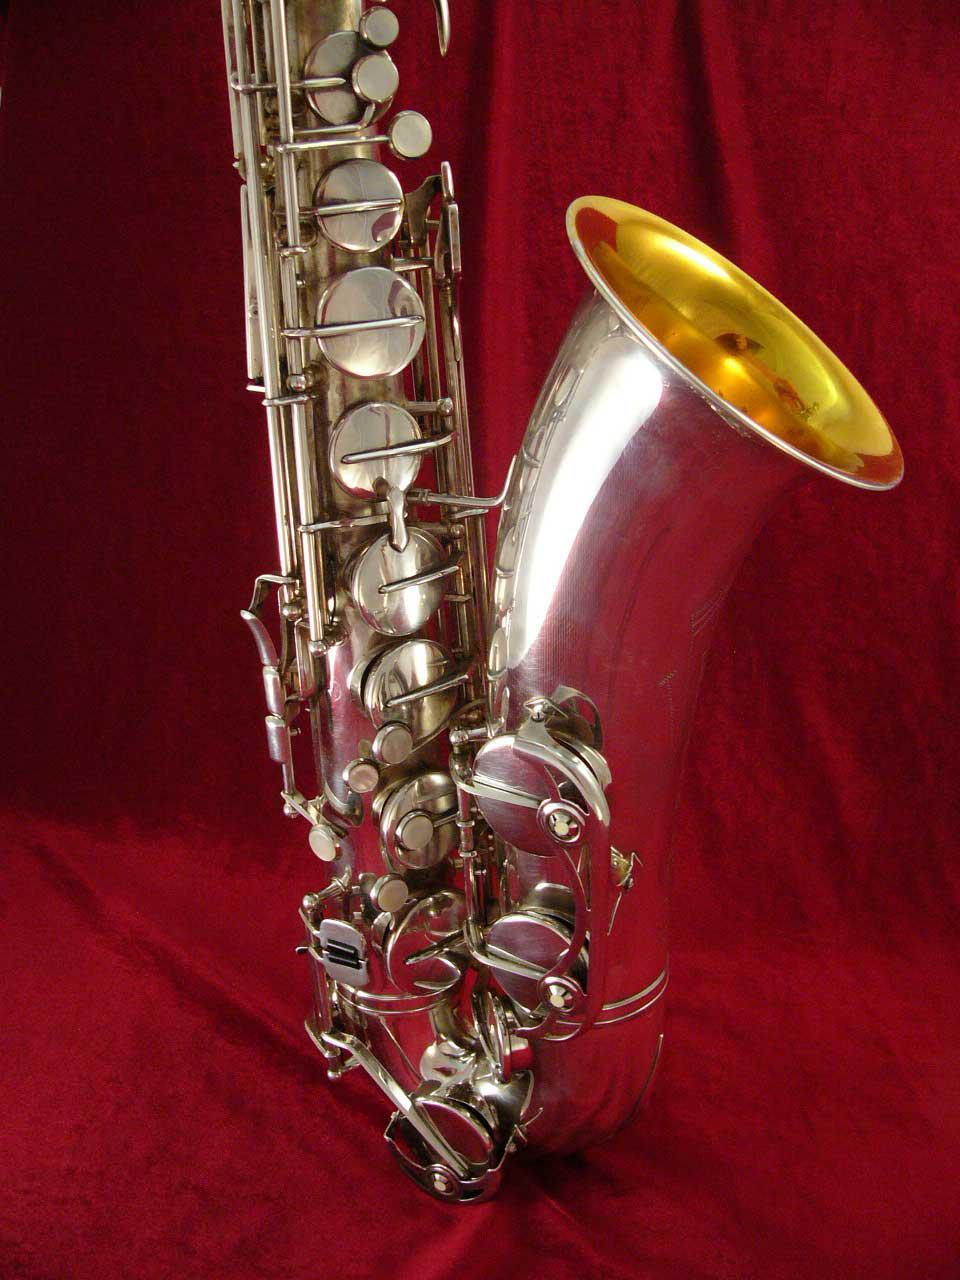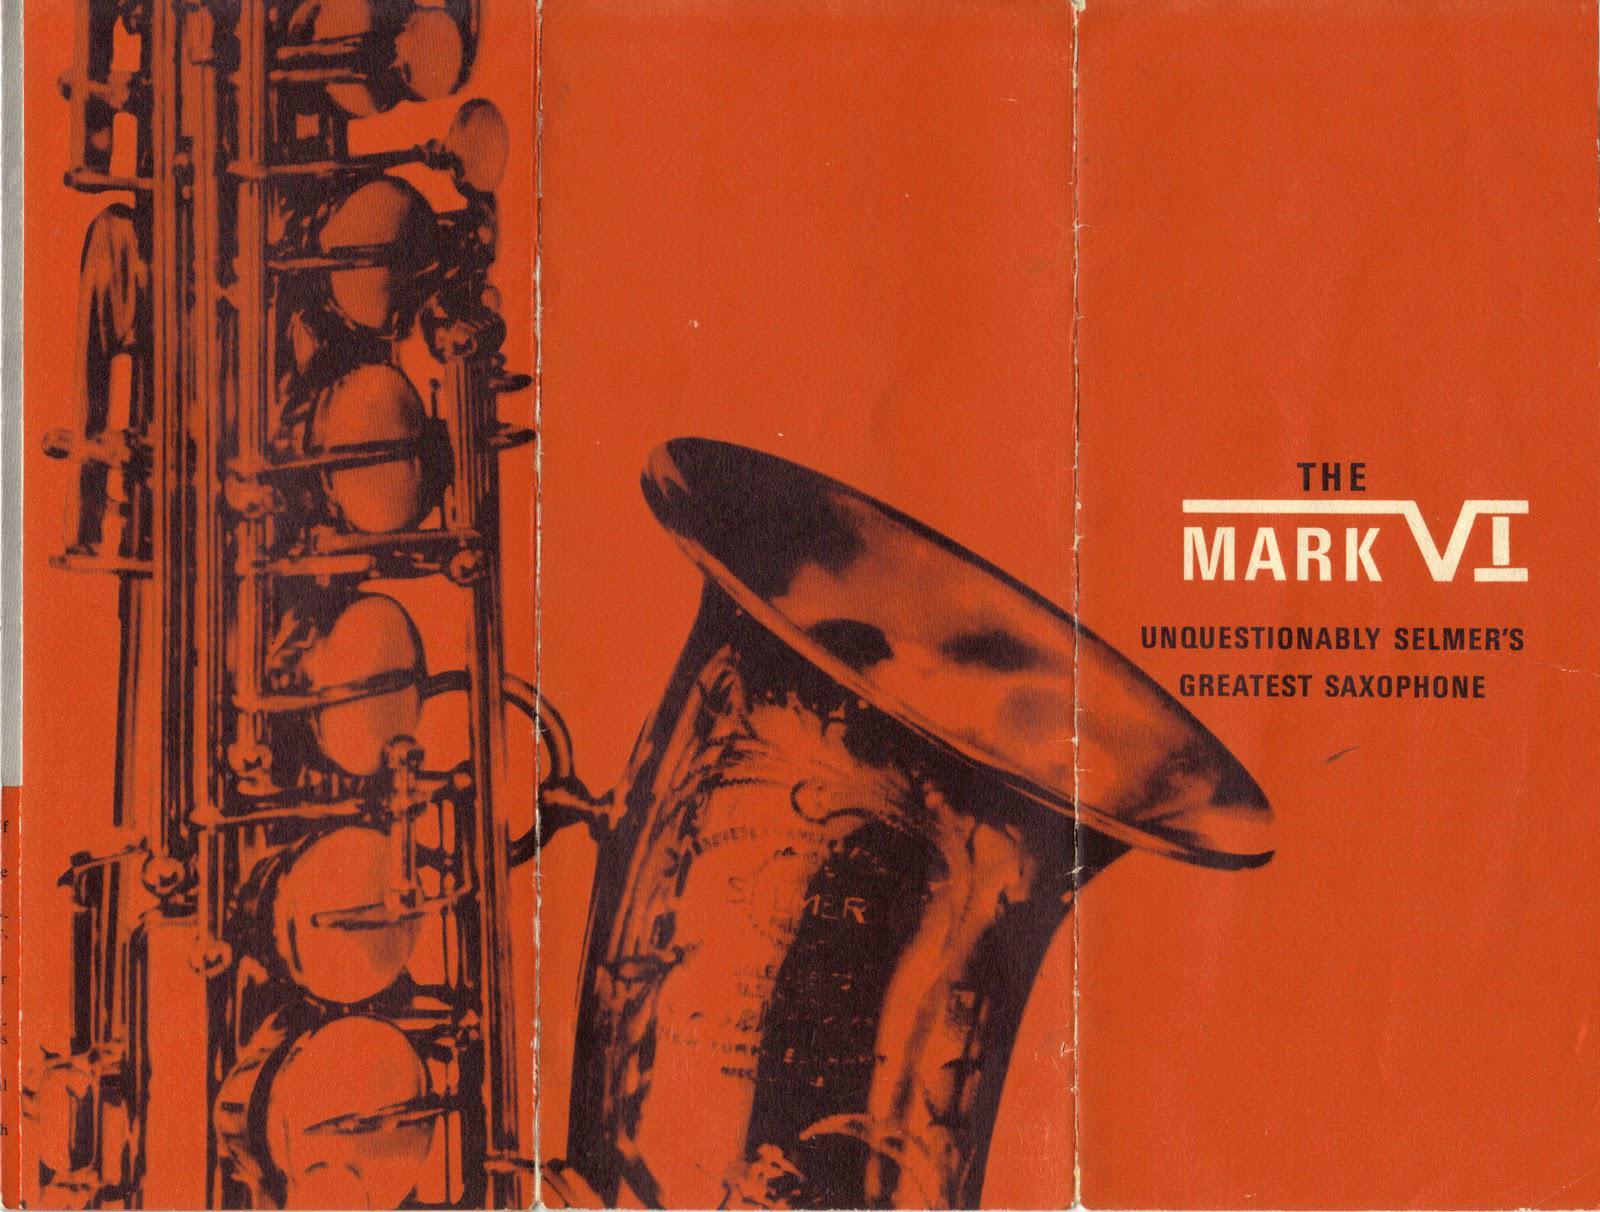The first image is the image on the left, the second image is the image on the right. For the images displayed, is the sentence "Has an image with more than one kind of saxophone." factually correct? Answer yes or no. No. The first image is the image on the left, the second image is the image on the right. Given the left and right images, does the statement "At least one image shows a straight instrument displayed next to a saxophone with a curved bell and mouthpiece." hold true? Answer yes or no. No. 